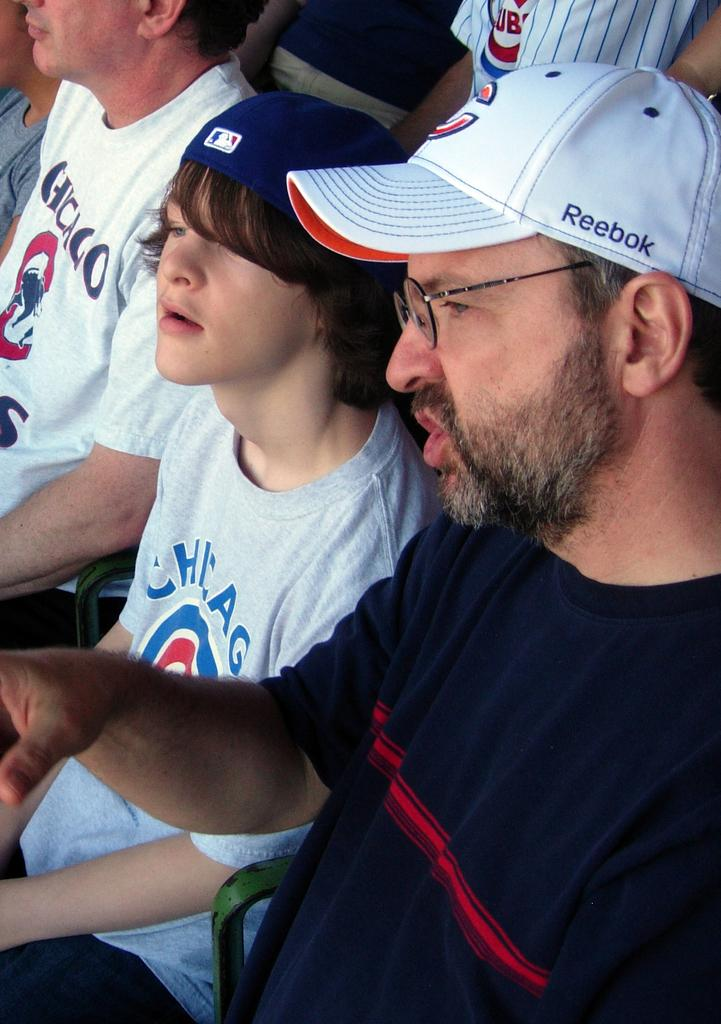Provide a one-sentence caption for the provided image. A boy wearing a Chiago cubs shirt sitting next to a bespectacled man. 